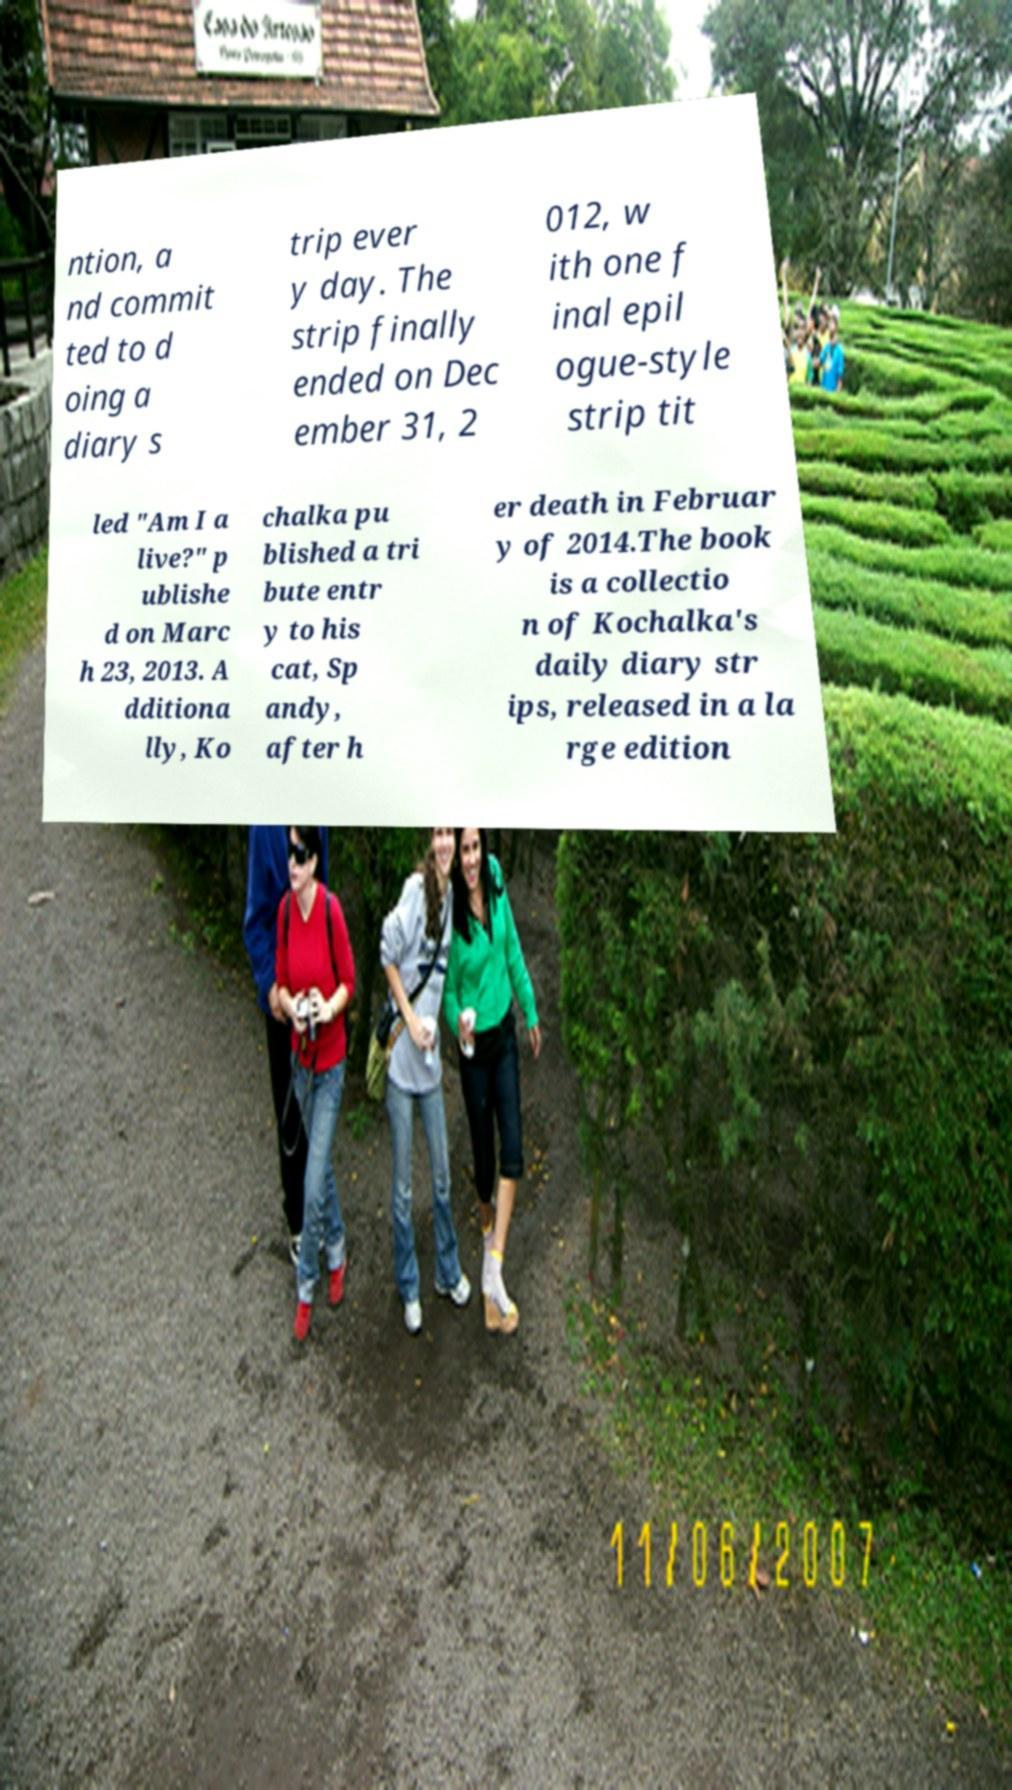Could you extract and type out the text from this image? ntion, a nd commit ted to d oing a diary s trip ever y day. The strip finally ended on Dec ember 31, 2 012, w ith one f inal epil ogue-style strip tit led "Am I a live?" p ublishe d on Marc h 23, 2013. A dditiona lly, Ko chalka pu blished a tri bute entr y to his cat, Sp andy, after h er death in Februar y of 2014.The book is a collectio n of Kochalka's daily diary str ips, released in a la rge edition 